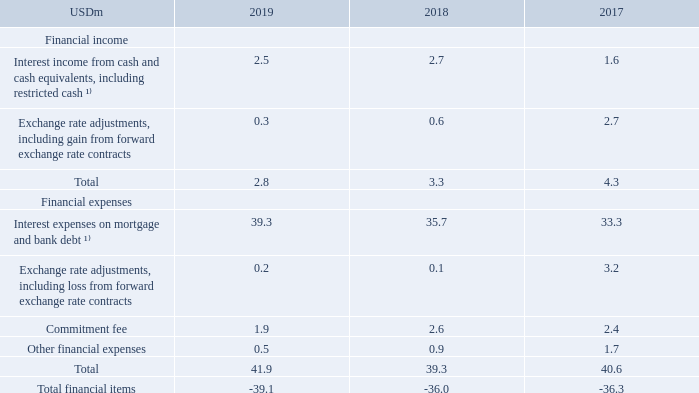NOTE 9 – FINANCIAL ITEMS
¹⁾ Interest for financial assets and liabilities not at fair value through profit and loss.
What is the total financial income for 2019?
Answer scale should be: million. 2.8. What is the amount of total financial items in 2019?
Answer scale should be: million. -39.1. What are the main categories analyzed under Financial Items in the table? Financial income, financial expenses. In which year was the amount of financial income the smallest? 2.8<3.3<4.3
Answer: 2019. What was the change in total financial expenses in 2019 from 2018?
Answer scale should be: million. 41.9-39.3
Answer: 2.6. What was the percentage change in total financial expenses in 2019 from 2018?
Answer scale should be: percent. (41.9-39.3)/39.3
Answer: 6.62. 